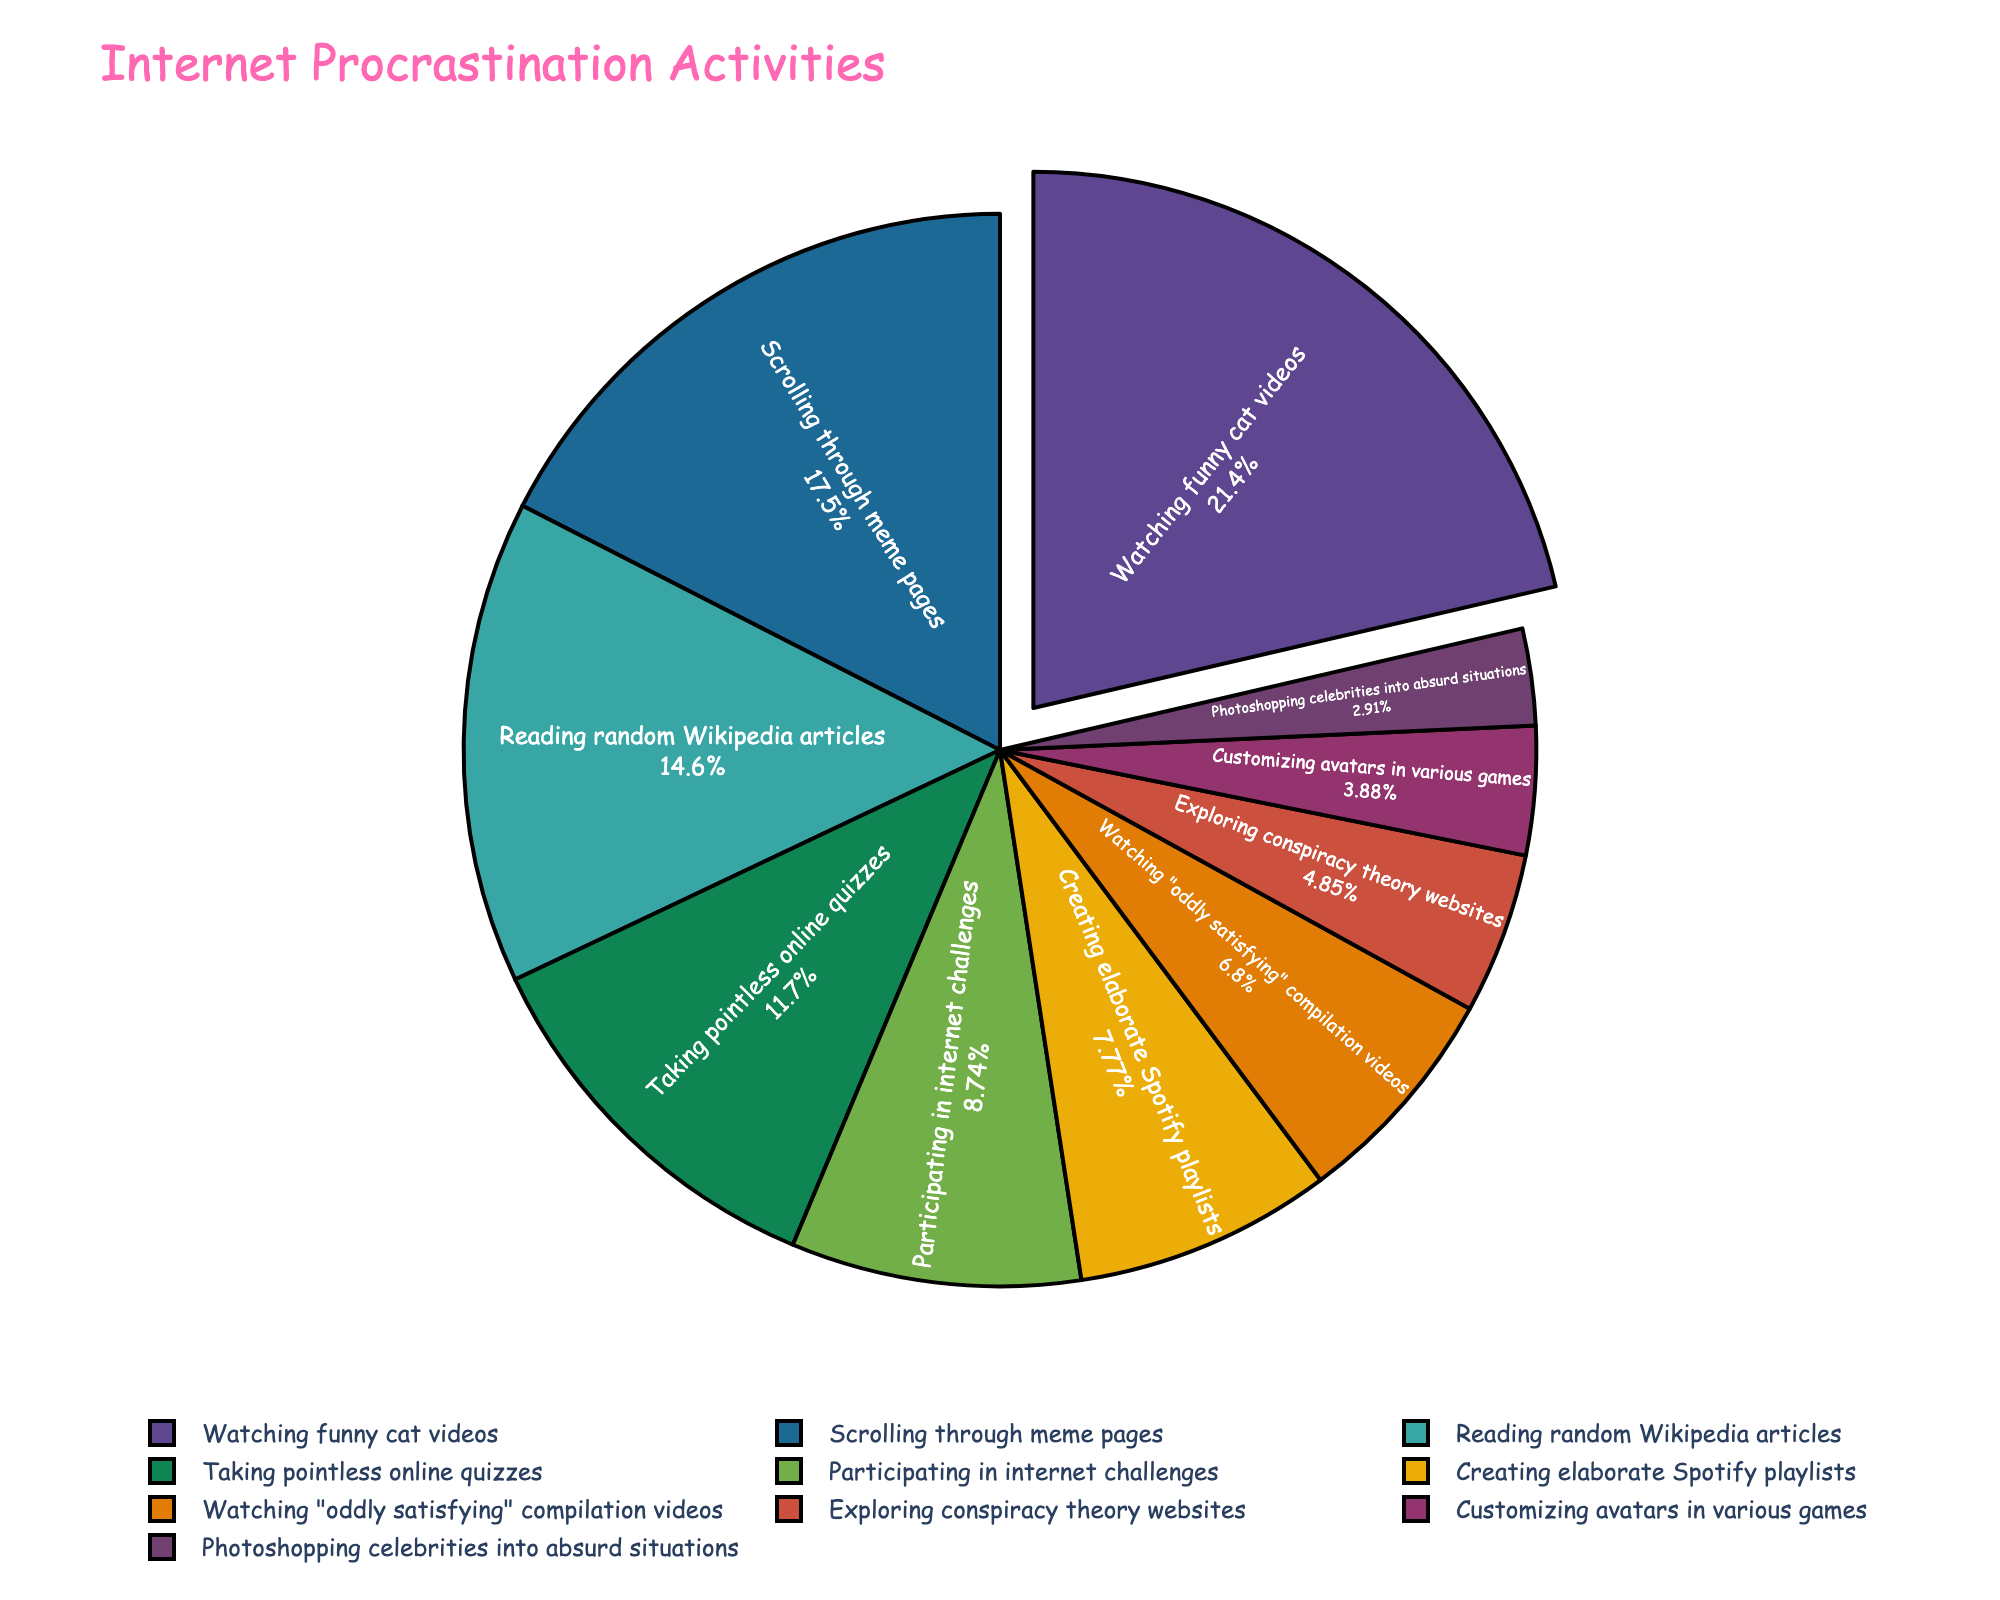Which activity has the highest percentage of time spent? Looking at the figure, the wedge with the largest size represents the activity with the highest percentage. In this case, it is "Watching funny cat videos" with 22%.
Answer: Watching funny cat videos How much more time is spent watching cat videos compared to customizing avatars? To find the difference, subtract the percentage for "Customizing avatars in various games" from "Watching funny cat videos": 22% - 4% = 18%.
Answer: 18% What percentage of time is spent on activities other than watching cat videos and scrolling through meme pages? Sum the percentages for these two activities: 22% (cat videos) + 18% (meme pages) = 40%. Subtract this sum from 100%: 100% - 40% = 60%.
Answer: 60% Is more time spent taking online quizzes or reading random Wikipedia articles? Compare the two percentages: 12% for taking quizzes and 15% for reading Wikipedia articles. 15% is greater than 12%.
Answer: Reading random Wikipedia articles What is the combined percentage of time spent on creating Spotify playlists, watching oddly satisfying videos, and exploring conspiracy theory websites? Add the percentages for these three activities: 8% (Spotify playlists) + 7% (oddly satisfying videos) + 5% (conspiracy theory websites) = 20%.
Answer: 20% Which activity has the smallest percentage time allocation? The smallest wedge in the pie chart represents "Photoshopping celebrities into absurd situations" with 3%.
Answer: Photoshopping celebrities into absurd situations Are the time percentages for participating in internet challenges and customizing avatars equal? The percentage for participating in internet challenges is 9%, and for customizing avatars, it is 4%. Since 9% is not equal to 4%, they are not equal.
Answer: No What is the average percentage time spent on reading Wikipedia articles and taking online quizzes? Sum the percentages and divide by 2: (15% + 12%) / 2 = 13.5%.
Answer: 13.5% Which two activities have a combined percentage that equals the time spent watching funny cat videos? To match 22%, sum any two activities that equal this amount. For example, 15% (Wikipedia articles) + 7% (oddly satisfying videos) = 22%.
Answer: Reading random Wikipedia articles and watching "oddly satisfying" videos How much more time is spent on scrolling through meme pages than on taking online quizzes? Subtract the percentage for taking online quizzes from scrolling through meme pages: 18% - 12% = 6%.
Answer: 6% 